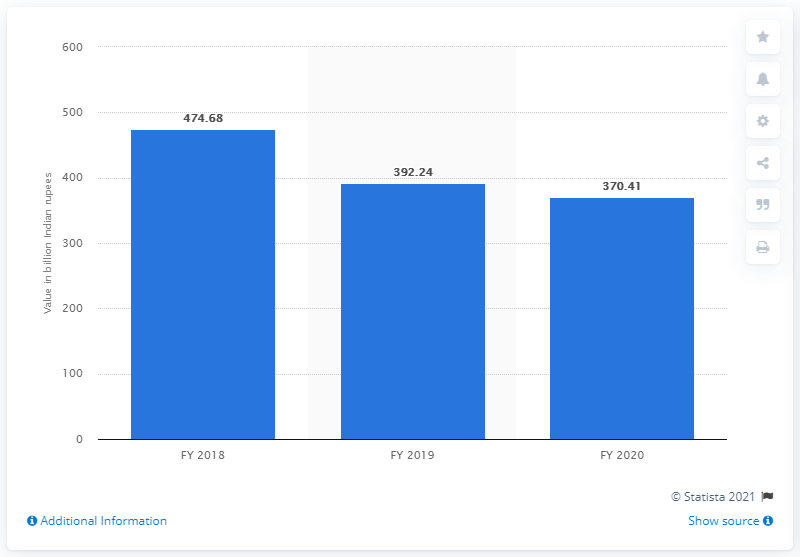Mention a couple of crucial points in this snapshot. Canara Bank's gross non-performing assets (NPAs) were worth 370.41 Indian rupees by the end of fiscal year 2020. 